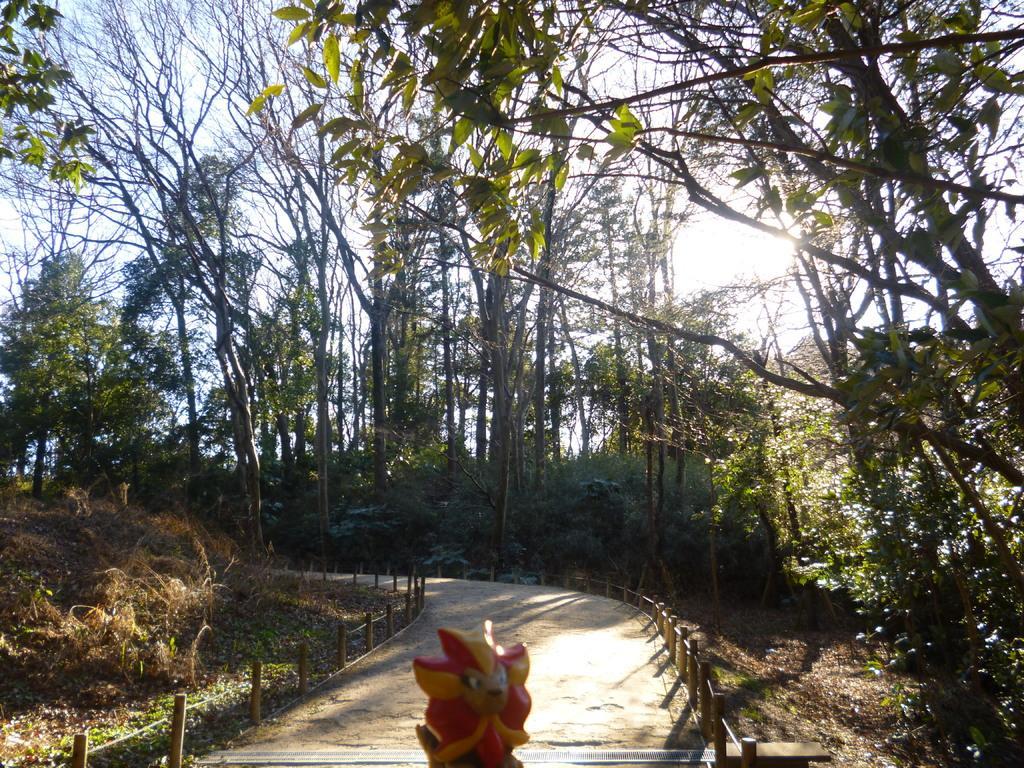Please provide a concise description of this image. In this picture I can see trees, plants and a toy and I can see path and a cloudy sky. 